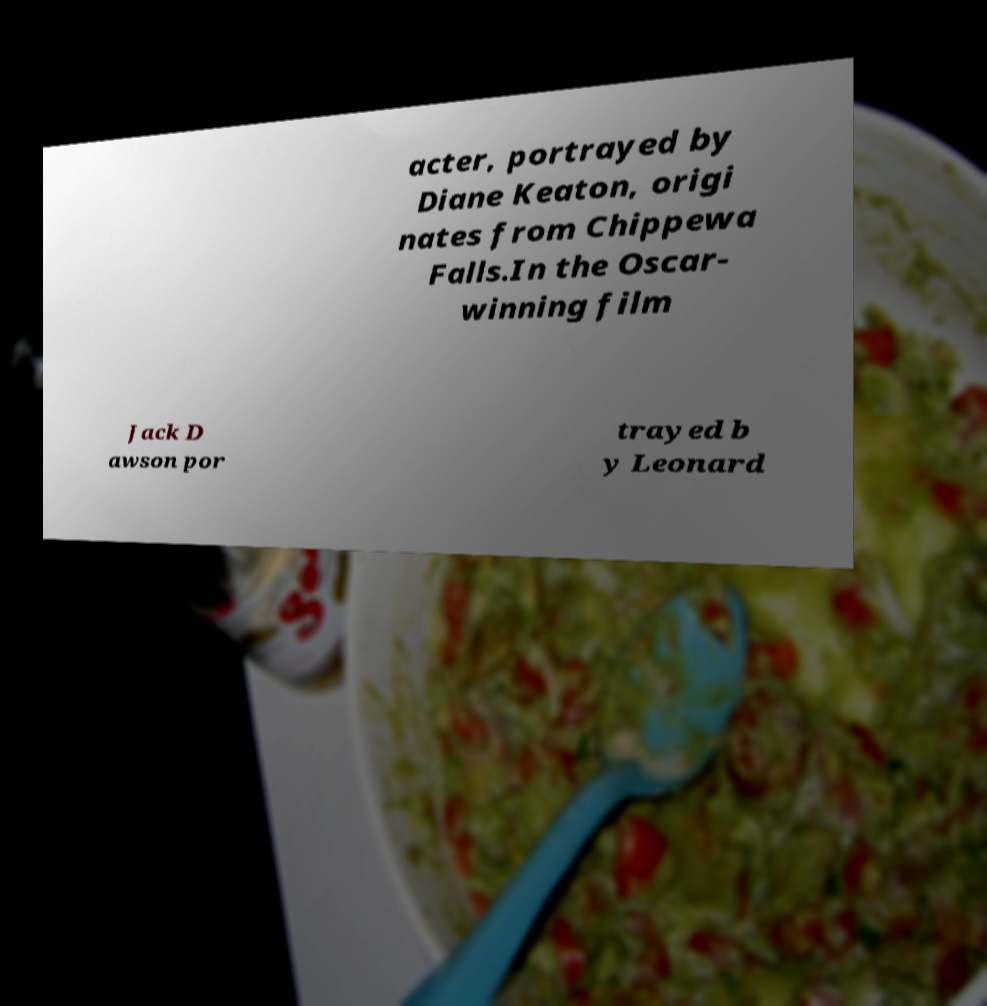For documentation purposes, I need the text within this image transcribed. Could you provide that? acter, portrayed by Diane Keaton, origi nates from Chippewa Falls.In the Oscar- winning film Jack D awson por trayed b y Leonard 